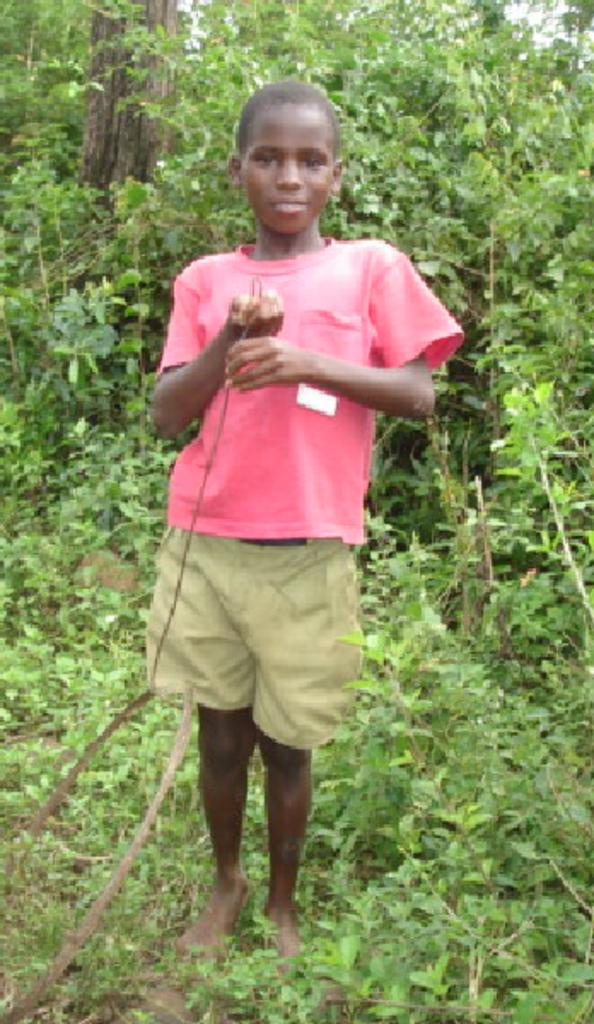What is the main subject of the image? There is a person standing in the middle of the image. What is the person holding in the image? The person is holding an object. What can be seen in the background of the image? There are trees visible behind the person. What type of vein is visible on the person's arm in the image? There is no visible vein on the person's arm in the image. What angle is the person standing at in the image? The angle at which the person is standing cannot be determined from the image. 